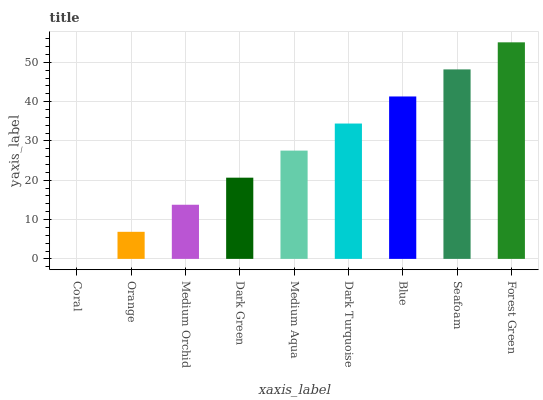Is Coral the minimum?
Answer yes or no. Yes. Is Forest Green the maximum?
Answer yes or no. Yes. Is Orange the minimum?
Answer yes or no. No. Is Orange the maximum?
Answer yes or no. No. Is Orange greater than Coral?
Answer yes or no. Yes. Is Coral less than Orange?
Answer yes or no. Yes. Is Coral greater than Orange?
Answer yes or no. No. Is Orange less than Coral?
Answer yes or no. No. Is Medium Aqua the high median?
Answer yes or no. Yes. Is Medium Aqua the low median?
Answer yes or no. Yes. Is Orange the high median?
Answer yes or no. No. Is Forest Green the low median?
Answer yes or no. No. 